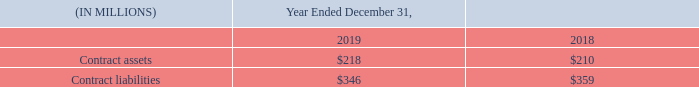Contract Assets and Liabilities
Contract assets represent the Company’s rights to consideration in exchange for services transferred to a customer that have not been billed as of the reporting date. While the Company’s rights to consideration are generally unconditional at the time its performance obligations are satisfied, under certain circumstances the related billing occurs in arrears, generally within one month of the services being rendered.
At the inception of a contract, the Company generally expects the period between when it transfers its services to its customers and when the customer pays for such services will be one year or less.
Contract liabilities relate to advance consideration received or the right to consideration that is unconditional from customers for which revenue is recognized when the performance obligation is satisfied and control transferred to the customer.
The table below sets forth the Company’s contract assets and contract liabilities from contracts with customers.
The increase in the contract assets balance during the period was primarily due to $203 million of revenue recognized that was not billed, in accordance with the terms of the contracts, as of December 31, 2019, offset by $193 million of contract assets included in the December 31, 2018 balance that were invoiced to Nielsen’s clients and therefore transferred to trade receivables.
The decrease in the contract liability balance during the period was primarily due to $326 million of advance consideration received or the right to consideration that is unconditional from customers for which revenue was not recognized during the period, offset by $337 million of revenue recognized during the period that had been included in the December 31, 2018 contract liability balance.
What was the cause of the increase in the contract assets balance? Due to $203 million of revenue recognized that was not billed, in accordance with the terms of the contracts, as of december 31, 2019, offset by $193 million of contract assets included in the december 31, 2018 balance that were invoiced to nielsen’s clients and therefore transferred to trade receivables. What was the cause of the decrease in contract liability balance? Due to $326 million of advance consideration received or the right to consideration that is unconditional from customers for which revenue was not recognized during the period, offset by $337 million of revenue recognized during the period that had been included in the december 31, 2018 contract liability balance. What is the contract assets for the year ended December 31, 2019?
Answer scale should be: million. 218. What is the percentage change in the contract assets from 2018 to 2019?
Answer scale should be: percent. (218-210)/210
Answer: 3.81. What is the percentage change in the contract liabilities from 2018 to 2019?
Answer scale should be: percent. (346-359)/359
Answer: -3.62. What is the change in the contract assets from 2018 to 2019?
Answer scale should be: million. 218-210
Answer: 8. 